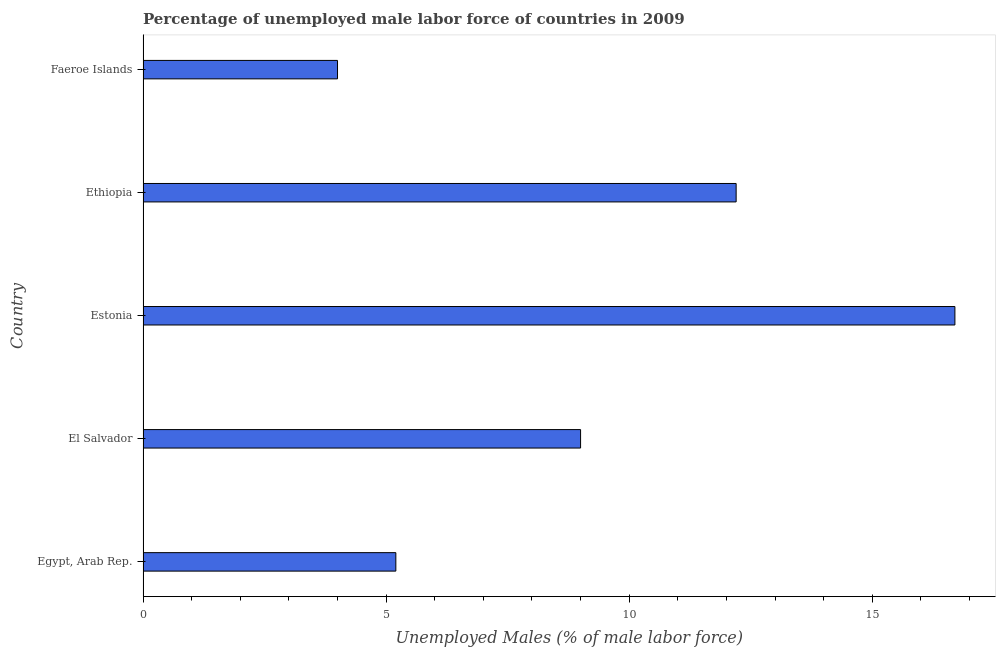Does the graph contain any zero values?
Provide a succinct answer. No. What is the title of the graph?
Give a very brief answer. Percentage of unemployed male labor force of countries in 2009. What is the label or title of the X-axis?
Offer a very short reply. Unemployed Males (% of male labor force). What is the total unemployed male labour force in Egypt, Arab Rep.?
Provide a succinct answer. 5.2. Across all countries, what is the maximum total unemployed male labour force?
Provide a succinct answer. 16.7. Across all countries, what is the minimum total unemployed male labour force?
Give a very brief answer. 4. In which country was the total unemployed male labour force maximum?
Your response must be concise. Estonia. In which country was the total unemployed male labour force minimum?
Make the answer very short. Faeroe Islands. What is the sum of the total unemployed male labour force?
Make the answer very short. 47.1. What is the difference between the total unemployed male labour force in Egypt, Arab Rep. and El Salvador?
Provide a short and direct response. -3.8. What is the average total unemployed male labour force per country?
Your answer should be compact. 9.42. What is the ratio of the total unemployed male labour force in El Salvador to that in Faeroe Islands?
Your answer should be compact. 2.25. What is the difference between the highest and the second highest total unemployed male labour force?
Give a very brief answer. 4.5. Is the sum of the total unemployed male labour force in Egypt, Arab Rep. and El Salvador greater than the maximum total unemployed male labour force across all countries?
Your response must be concise. No. What is the difference between the highest and the lowest total unemployed male labour force?
Provide a succinct answer. 12.7. In how many countries, is the total unemployed male labour force greater than the average total unemployed male labour force taken over all countries?
Keep it short and to the point. 2. Are all the bars in the graph horizontal?
Your answer should be very brief. Yes. What is the Unemployed Males (% of male labor force) in Egypt, Arab Rep.?
Your answer should be very brief. 5.2. What is the Unemployed Males (% of male labor force) of El Salvador?
Your response must be concise. 9. What is the Unemployed Males (% of male labor force) in Estonia?
Your response must be concise. 16.7. What is the Unemployed Males (% of male labor force) of Ethiopia?
Provide a short and direct response. 12.2. What is the Unemployed Males (% of male labor force) of Faeroe Islands?
Make the answer very short. 4. What is the difference between the Unemployed Males (% of male labor force) in Egypt, Arab Rep. and El Salvador?
Ensure brevity in your answer.  -3.8. What is the difference between the Unemployed Males (% of male labor force) in El Salvador and Estonia?
Your answer should be very brief. -7.7. What is the difference between the Unemployed Males (% of male labor force) in El Salvador and Ethiopia?
Provide a short and direct response. -3.2. What is the ratio of the Unemployed Males (% of male labor force) in Egypt, Arab Rep. to that in El Salvador?
Offer a very short reply. 0.58. What is the ratio of the Unemployed Males (% of male labor force) in Egypt, Arab Rep. to that in Estonia?
Keep it short and to the point. 0.31. What is the ratio of the Unemployed Males (% of male labor force) in Egypt, Arab Rep. to that in Ethiopia?
Your answer should be very brief. 0.43. What is the ratio of the Unemployed Males (% of male labor force) in Egypt, Arab Rep. to that in Faeroe Islands?
Give a very brief answer. 1.3. What is the ratio of the Unemployed Males (% of male labor force) in El Salvador to that in Estonia?
Offer a very short reply. 0.54. What is the ratio of the Unemployed Males (% of male labor force) in El Salvador to that in Ethiopia?
Offer a terse response. 0.74. What is the ratio of the Unemployed Males (% of male labor force) in El Salvador to that in Faeroe Islands?
Offer a terse response. 2.25. What is the ratio of the Unemployed Males (% of male labor force) in Estonia to that in Ethiopia?
Ensure brevity in your answer.  1.37. What is the ratio of the Unemployed Males (% of male labor force) in Estonia to that in Faeroe Islands?
Your answer should be very brief. 4.17. What is the ratio of the Unemployed Males (% of male labor force) in Ethiopia to that in Faeroe Islands?
Your answer should be compact. 3.05. 